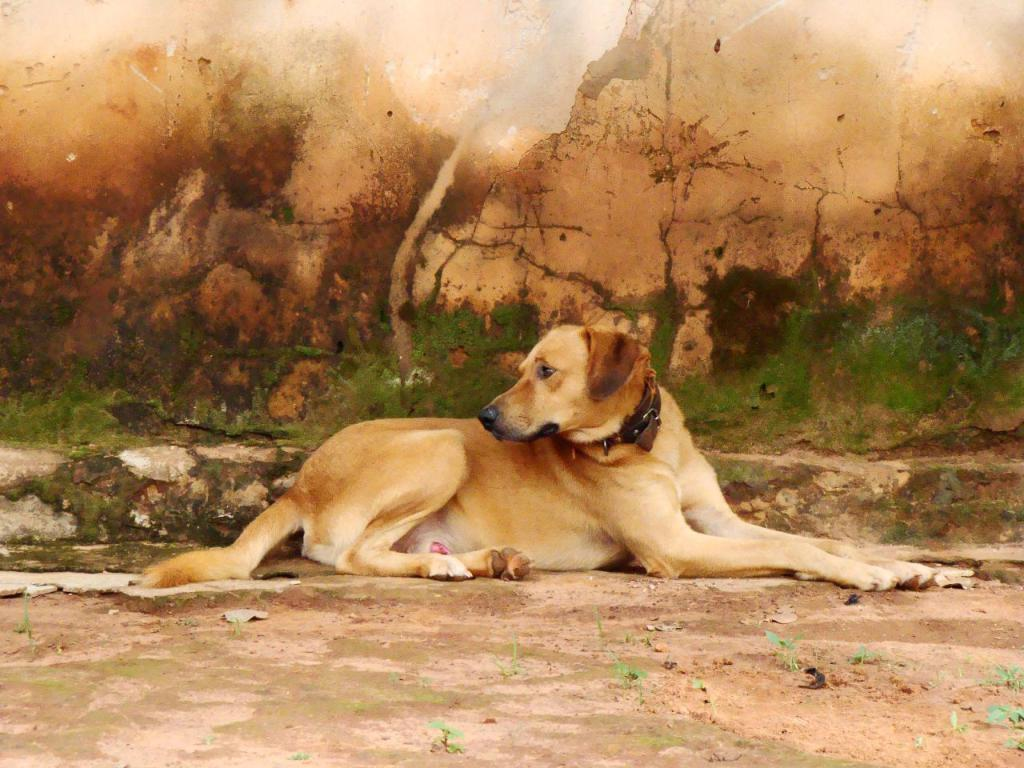What type of animal is present in the image? There is a dog in the image. What can be seen in the background of the image? There is a wall in the background of the image. What is on the ground in the image? There are plants on the ground in the image. What type of clam is visible on the wall in the image? There is no clam present in the image; the background features a wall without any clams. 